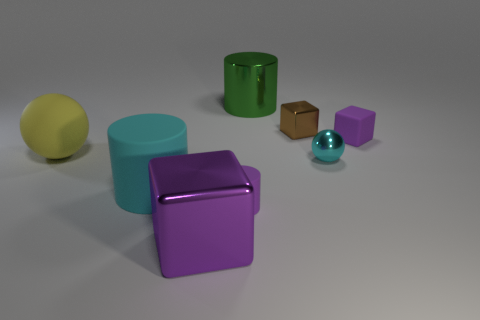Subtract all shiny cylinders. How many cylinders are left? 2 Add 2 green metal objects. How many objects exist? 10 Subtract 2 balls. How many balls are left? 0 Subtract all cyan spheres. How many spheres are left? 1 Subtract all purple matte objects. Subtract all big green cylinders. How many objects are left? 5 Add 3 big yellow matte objects. How many big yellow matte objects are left? 4 Add 7 large blue blocks. How many large blue blocks exist? 7 Subtract 0 gray balls. How many objects are left? 8 Subtract all spheres. How many objects are left? 6 Subtract all red blocks. Subtract all cyan balls. How many blocks are left? 3 